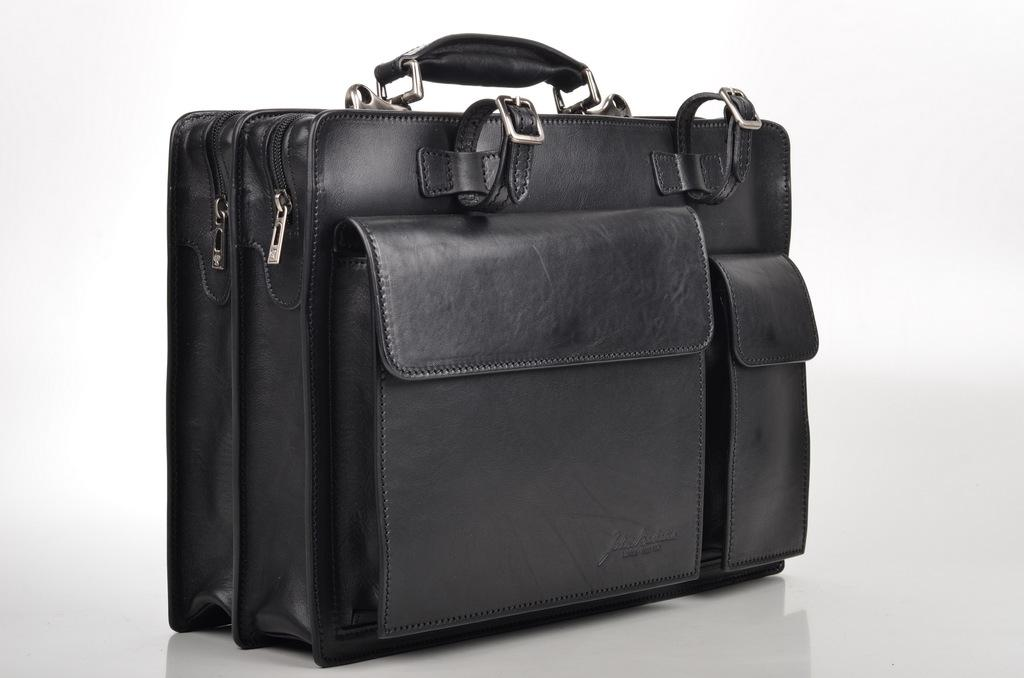What color is the bag that is visible in the image? The bag in the image is black colored. What is the color of the background in the image? The background of the image is white. Is there a hat or crown visible on the bag in the image? No, there is no hat or crown visible on the bag in the image. 